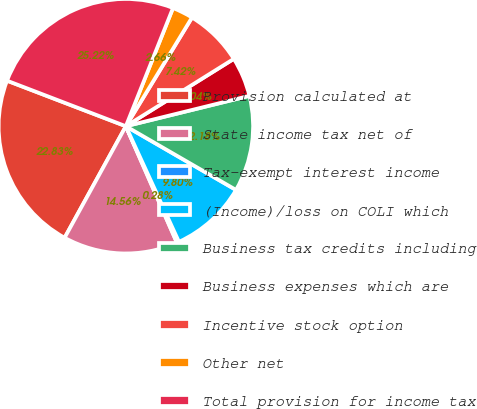Convert chart. <chart><loc_0><loc_0><loc_500><loc_500><pie_chart><fcel>Provision calculated at<fcel>State income tax net of<fcel>Tax-exempt interest income<fcel>(Income)/loss on COLI which<fcel>Business tax credits including<fcel>Business expenses which are<fcel>Incentive stock option<fcel>Other net<fcel>Total provision for income tax<nl><fcel>22.83%<fcel>14.56%<fcel>0.28%<fcel>9.8%<fcel>12.18%<fcel>5.04%<fcel>7.42%<fcel>2.66%<fcel>25.21%<nl></chart> 